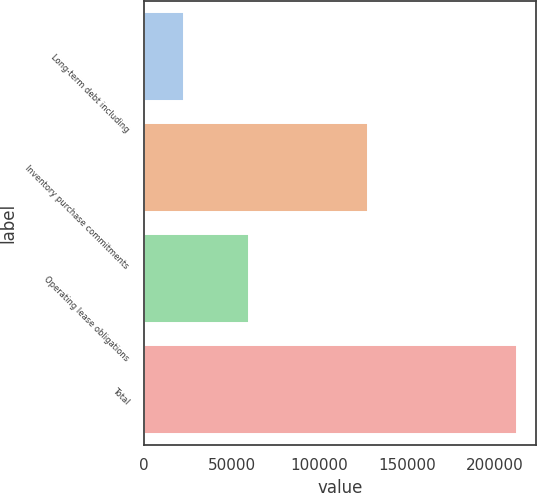Convert chart. <chart><loc_0><loc_0><loc_500><loc_500><bar_chart><fcel>Long-term debt including<fcel>Inventory purchase commitments<fcel>Operating lease obligations<fcel>Total<nl><fcel>23129<fcel>127518<fcel>60100<fcel>212706<nl></chart> 